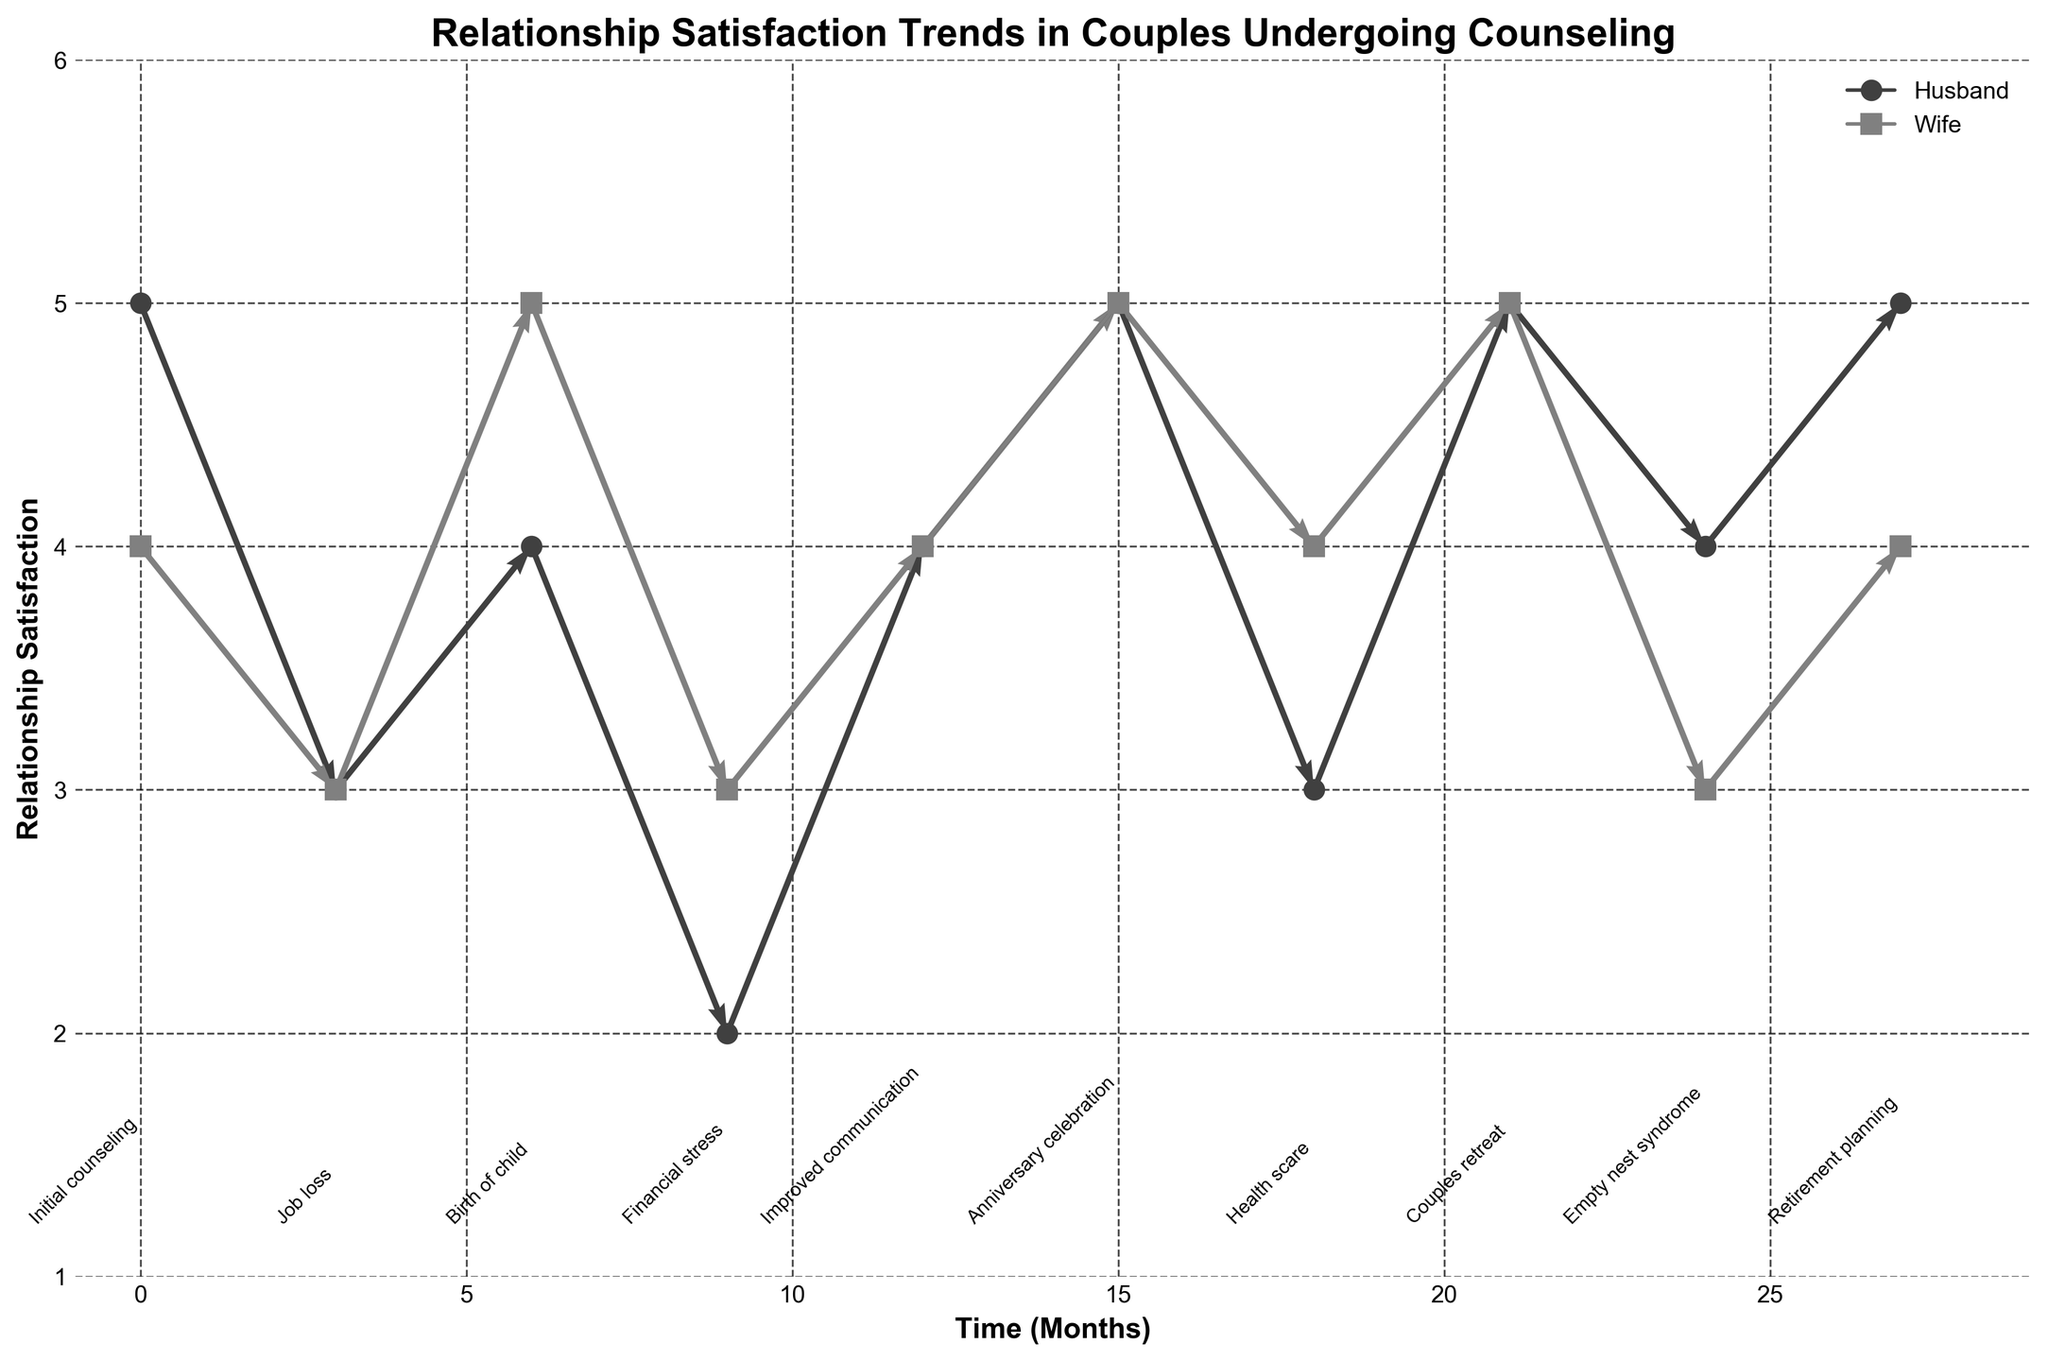What is the title of the figure? The title of the figure is usually placed at the top and contextualizes the entire plot. In this case, it helps identify the main focus of the data visualized.
Answer: Relationship Satisfaction Trends in Couples Undergoing Counseling What is the time range shown on the x-axis? The x-axis shows the time in months from the start of the counseling period. The data points range from the initial counseling session to the final data point at the 27th month. This can be determined from the labels on the x-axis and the time data provided.
Answer: 0 to 27 months How does the relationship satisfaction of the husband change during the "Financial stress" event? By examining the quiver arrows and the plotted points, the relationship satisfaction of the husband decreases from 4 to 2 during the financial stress event.
Answer: Decreases Which event shows the greatest decrease in satisfaction for both husband and wife? To determine the event with the greatest decrease, look for the longest downward arrows in both plots for the husband and wife. The "Financial stress" event shows the satisfaction decreasing for both individuals (Husband: -2, Wife: -2).
Answer: Financial stress Compare the satisfaction levels between husbands and wives at the "Birth of child" event. At the "Birth of child" event, the satisfaction levels for both the husband and wife can be directly read from the plot. The husband's satisfaction is at 4, and the wife’s satisfaction is at 5.
Answer: Husband: 4, Wife: 5 During which event do the husband and wife reach an equal relationship satisfaction level for the first time after the initial counseling? From the plotted points and annotations, the satisfaction levels can be compared event by event. Both reach an equal satisfaction level at "Job loss" with a score of 3.
Answer: Job loss How much does the husband's satisfaction change from "Improved communication" to "Anniversary celebration"? Examine the quiver arrows between the corresponding points. The change in satisfaction for the husband is 0.5, increasing from 4 to 5.
Answer: 0.5 What event occurs at the 24th month, and how do the satisfaction levels of the husband and wife compare? By identifying the event annotation at the 24th month and the corresponding points, the event is "Empty nest syndrome." At this point, the husband's satisfaction is 4, and the wife’s satisfaction is 3.
Answer: Empty nest syndrome, Husband: 4, Wife: 3 What is the color used to represent the wife's satisfaction? Different markers and colors differentiate the husband’s and wife’s satisfaction. The wife’s satisfaction is represented by a gray square marker and line.
Answer: Gray During which events does the wife's satisfaction remain unchanged? Find the events where the wife's satisfaction does not show any vertical movement. The wife’s satisfaction remains unchanged during "Job loss" and "Couples retreat".
Answer: Job loss, Couples retreat 